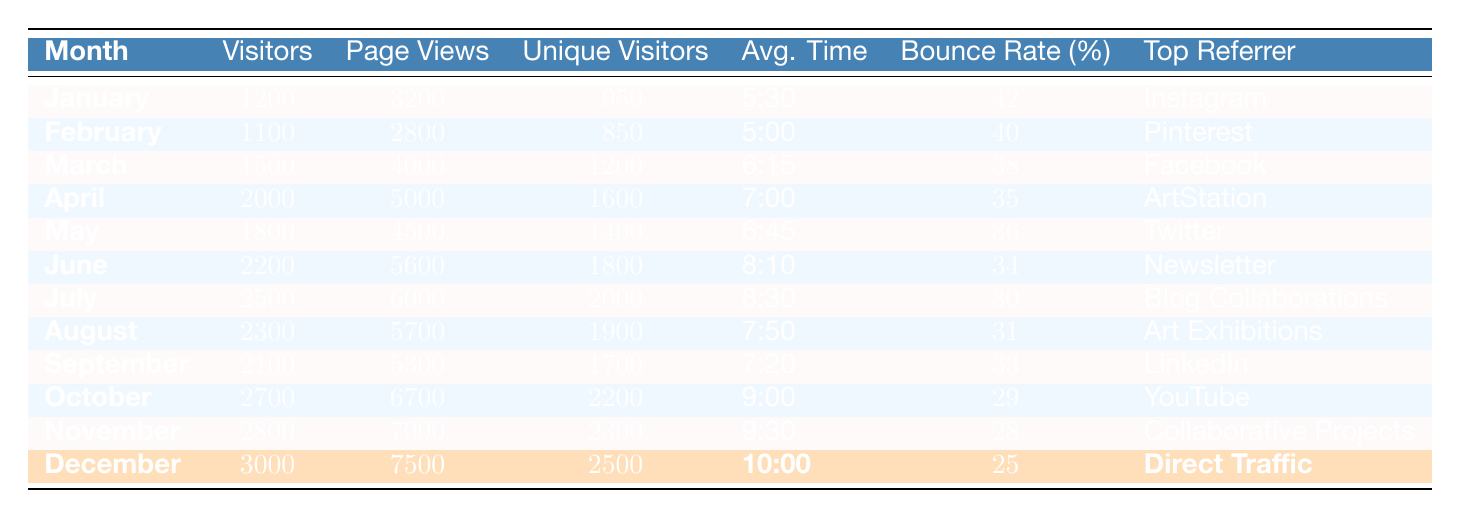What month had the highest number of visitors? Looking through the "Visitors" column, I can see that December has the highest value at 3000 visitors.
Answer: December What is the average bounce rate from January to March? First, I look at the bounce rates for January (42%), February (40%), and March (38%). I then compute the average: (42 + 40 + 38) / 3 = 40.
Answer: 40% Which month had the lowest average time on site? By scanning the "Avg. Time" column, I note that February has the lowest average time at 5:00.
Answer: February Is the number of unique visitors in April greater than the number in February? I compare the unique visitors: April has 1600 and February has 850. Since 1600 is greater than 850, the statement is true.
Answer: Yes How much did the number of page views increase from January to June? I find the page views for January (3200) and June (5600), then calculate the increase: 5600 - 3200 = 2400.
Answer: 2400 What is the total number of visitors from June to December? I add the number of visitors from each month: June (2200), July (2500), August (2300), September (2100), October (2700), November (2800), and December (3000). The total is 2200 + 2500 + 2300 + 2100 + 2700 + 2800 + 3000 = 19600.
Answer: 19600 In which month were the page views the highest, and what was the number? Scanning the "Page Views" column, I see that December has the highest value at 7500.
Answer: December, 7500 What percentage of unique visitors in October is represented compared to the total unique visitors from the beginning of the year? I first sum the unique visitors from January (950), February (850), March (1200), April (1600), May (1400), June (1800), July (2000), August (1900), September (1700), October (2200), November (2300), December (2500) for a total of 15,250. Then I find the percentage: (2200 / 15250) * 100 = 14.43%.
Answer: Approximately 14.43% Which month saw a decrease in visitors from the previous month? Comparing the visitors month-by-month, I see that there is no decrease in visitors from January to June. However, the August value (2300) is less than July (2500).
Answer: August What is the ratio of visitors in December to the visitors in January? I calculate the ratio of December (3000) to January (1200): 3000 / 1200 = 2.5.
Answer: 2.5 